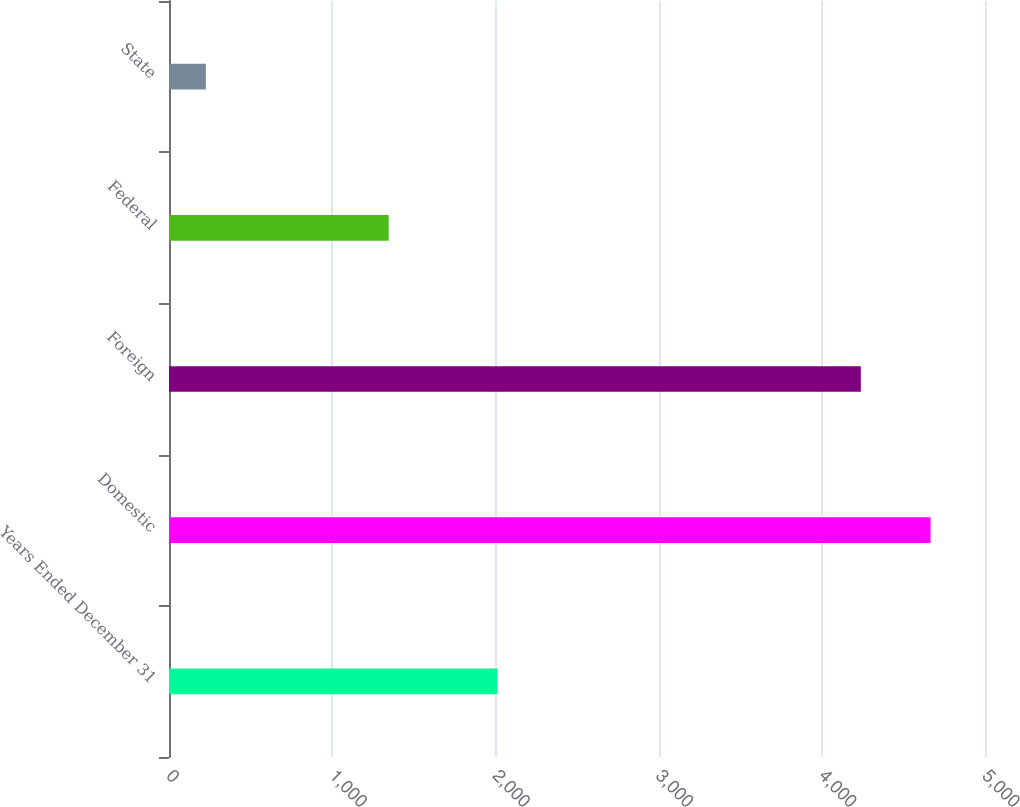Convert chart to OTSL. <chart><loc_0><loc_0><loc_500><loc_500><bar_chart><fcel>Years Ended December 31<fcel>Domestic<fcel>Foreign<fcel>Federal<fcel>State<nl><fcel>2012<fcel>4666.4<fcel>4239<fcel>1346<fcel>226<nl></chart> 